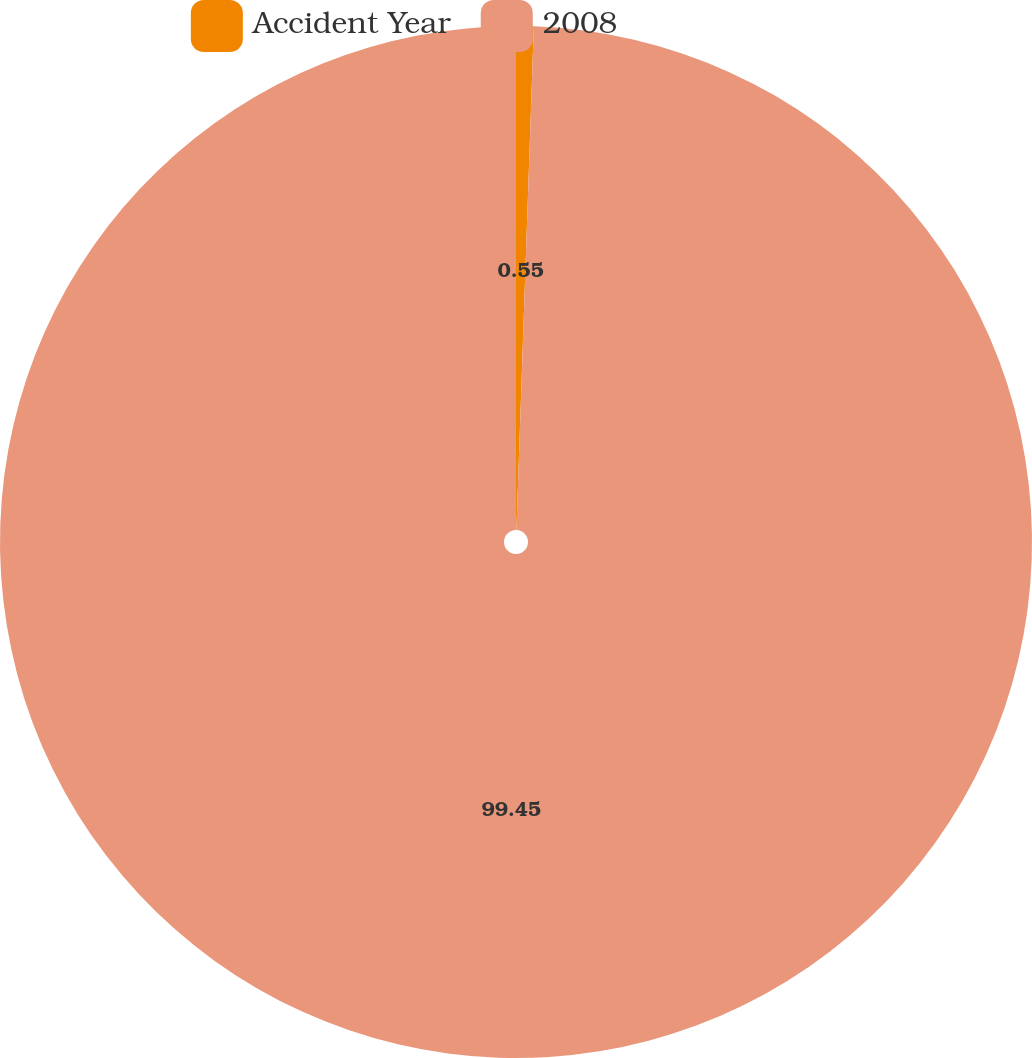<chart> <loc_0><loc_0><loc_500><loc_500><pie_chart><fcel>Accident Year<fcel>2008<nl><fcel>0.55%<fcel>99.45%<nl></chart> 